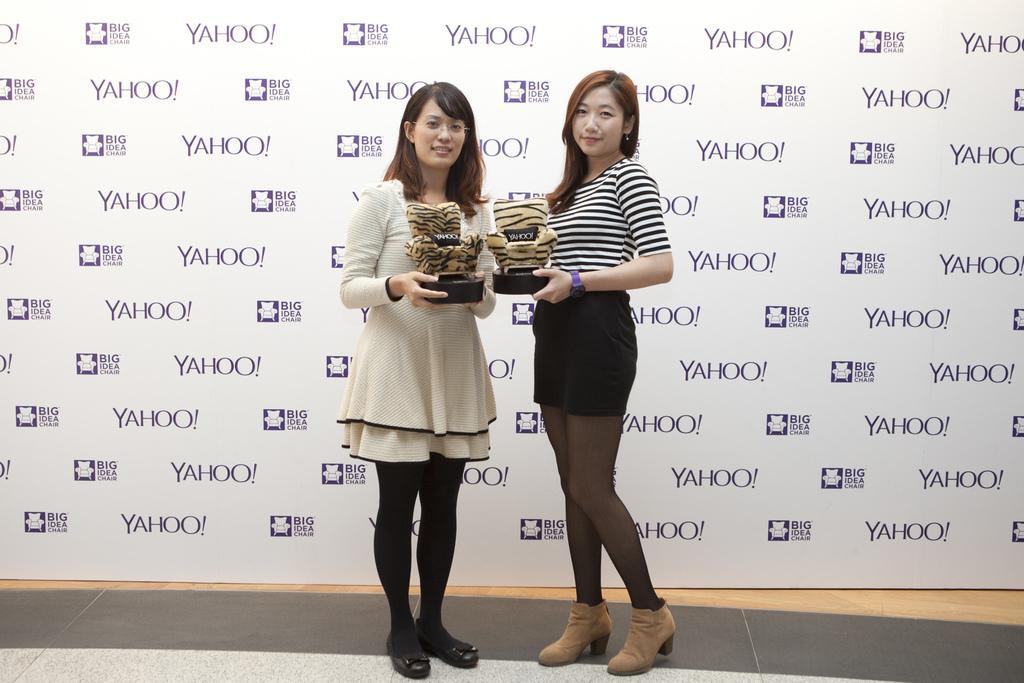Describe this image in one or two sentences. Hear I can see two women are holding some objects in their hands, standing, smiling and giving pose for the picture. In the background, I can see a white color board on which I can see some text. 